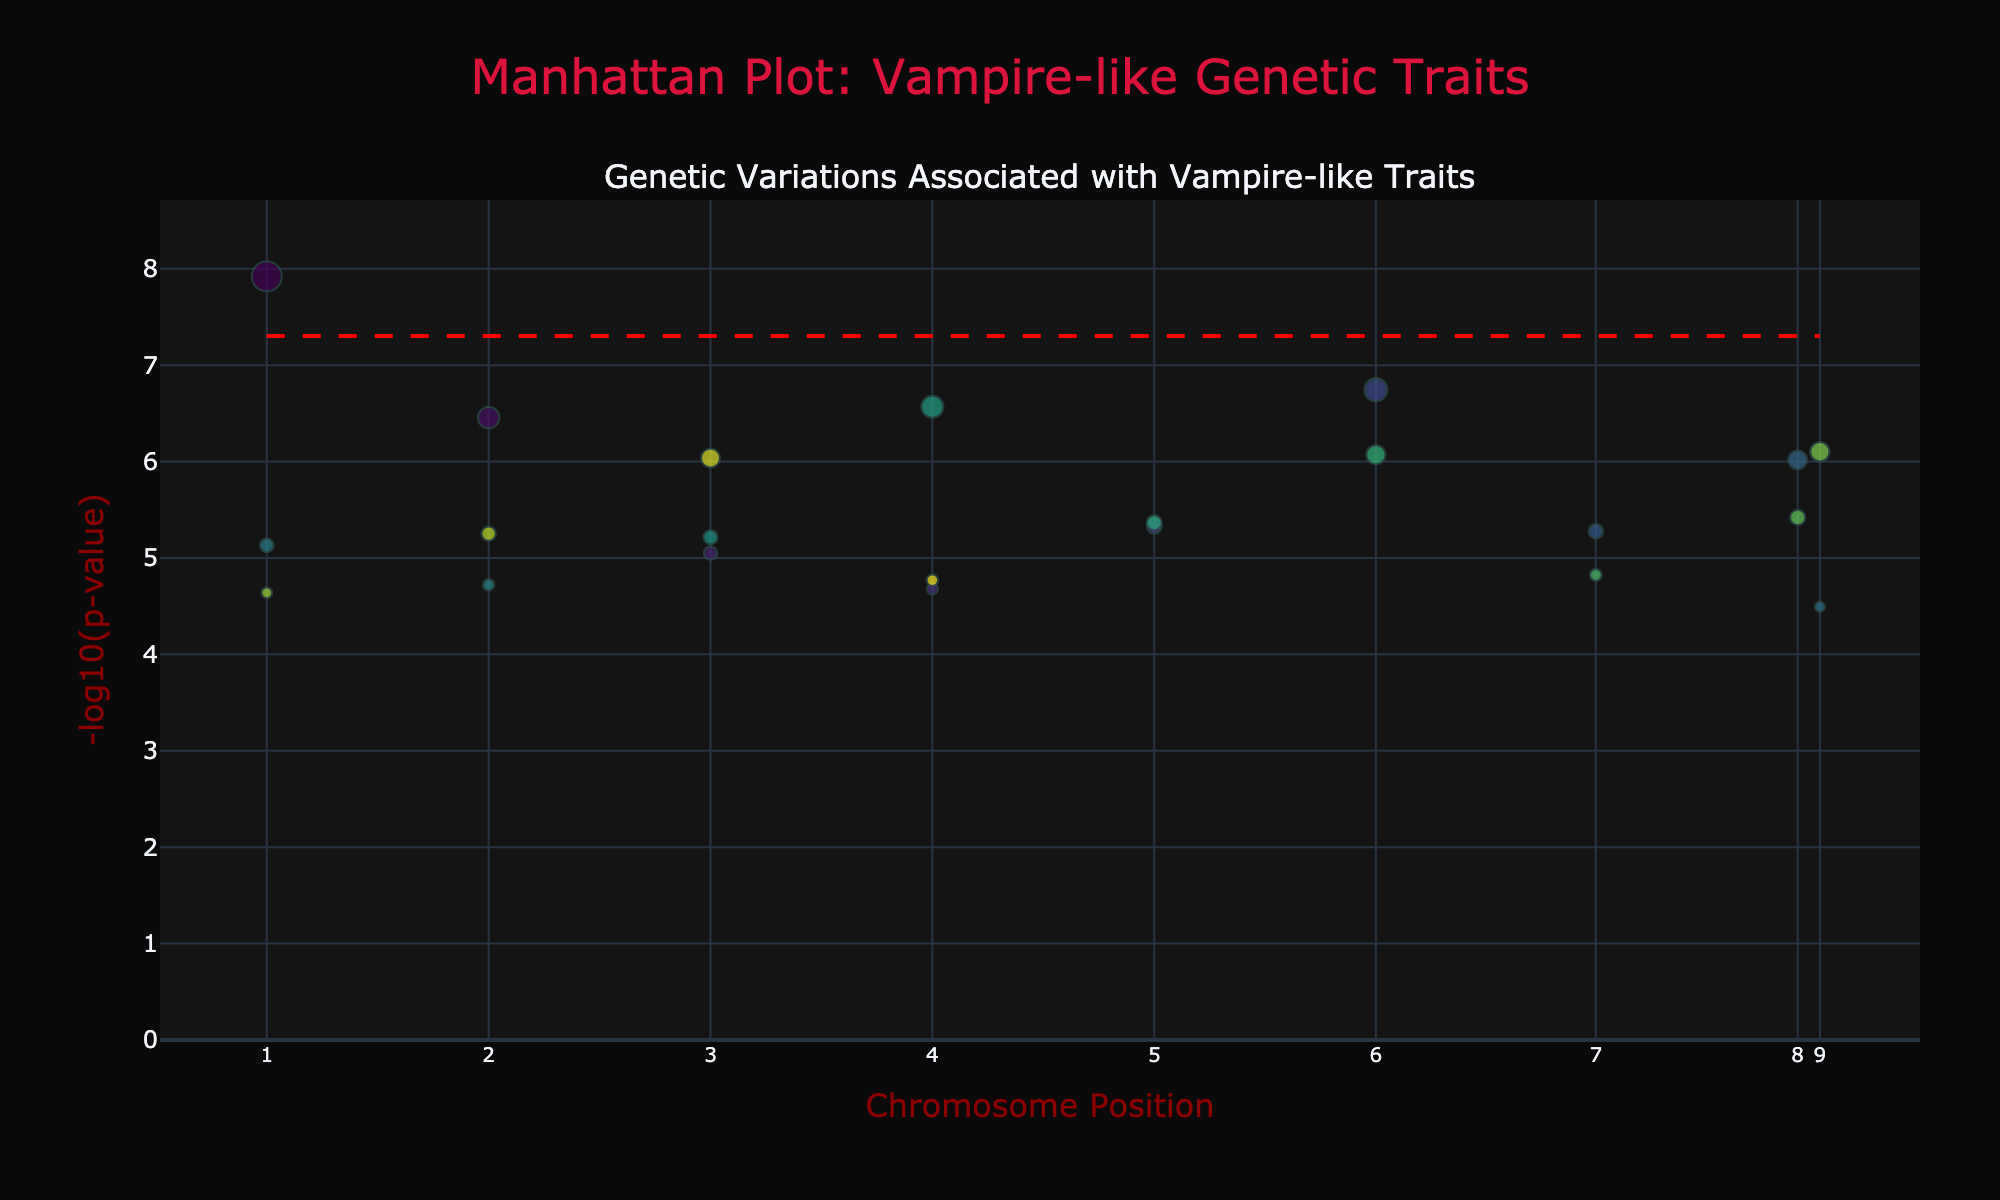What is the title of the plot? The title of the plot is shown at the top middle of the figure and is stated as 'Manhattan Plot: Vampire-like Genetic Traits'.
Answer: Manhattan Plot: Vampire-like Genetic Traits What are the labels of the X and Y axes? The X-axis is labeled as 'Chromosome Position' and is marked with positions and corresponding chromosome numbers, while the Y-axis is labeled as '-log10(p-value)' indicating the transformed P-values.
Answer: Chromosome Position, -log10(p-value) What is the significance threshold for the P-values? The significance threshold is represented by a red dashed line on the plot. The value corresponds to the P-value threshold of 5e-8, which is transformed into -log10(5e-8).
Answer: 5e-8 Which gene is associated with the highest -log10(p-value)? By observing the Y-axis, the gene associated with the highest -log10(p-value) is visible at the topmost position of the markers. The label provided indicates that the gene is FOXP2.
Answer: FOXP2 How many traits have a -log10(p-value) higher than 6? To determine this, count the number of points on the plot above the horizontal line at -log10(p-value) = 6. There are ten markers above this line.
Answer: 10 Which chromosome has the most genetic variations associated with vampire-like traits as shown in the plot? By examining the colors and hover information of the points, the chromosome with the highest frequency of markers is 10.
Answer: 10 Which genetic variation is related to pain sensitivity, and what is its -log10(p-value)? Hover information can be used to identify the trait listed. For pain sensitivity, the associated gene is TRPV1, and the corresponding -log10(p-value) is close to -log10(9.6e-7).
Answer: TRPV1, ~6.02 Compare the -log10(p-value) of the genes related to bone density and canine tooth development. Which one is higher? Locate the markers for LRP5 (bone density) and EDAR (canine tooth development) on the plot. By comparing their Y-axis values, EDAR's -log10(p-value) is higher than LRP5's.
Answer: EDAR What is the average -log10(p-value) for the genes related to iron absorption, body odor, and prion resistance? Sum the -log10(p-values) of HFE (8.6), ABCC11 (6.1), and PRNP (4.5), then divide by 3. The average is (8.95 + 6.1 + 4.5)/3 ≈ 6.52.
Answer: ~6.52 If a gene has a -log10(p-value) of 7, how many times more significant is it compared to a gene with a -log10(p-value) of 5? Since -log10(p-value) is the log transformation of the P-value, we compute the ratio by calculating 10^(-5)/10^(-7) = 100. The gene with -log10(p-value) of 7 is 100 times more significant.
Answer: 100 